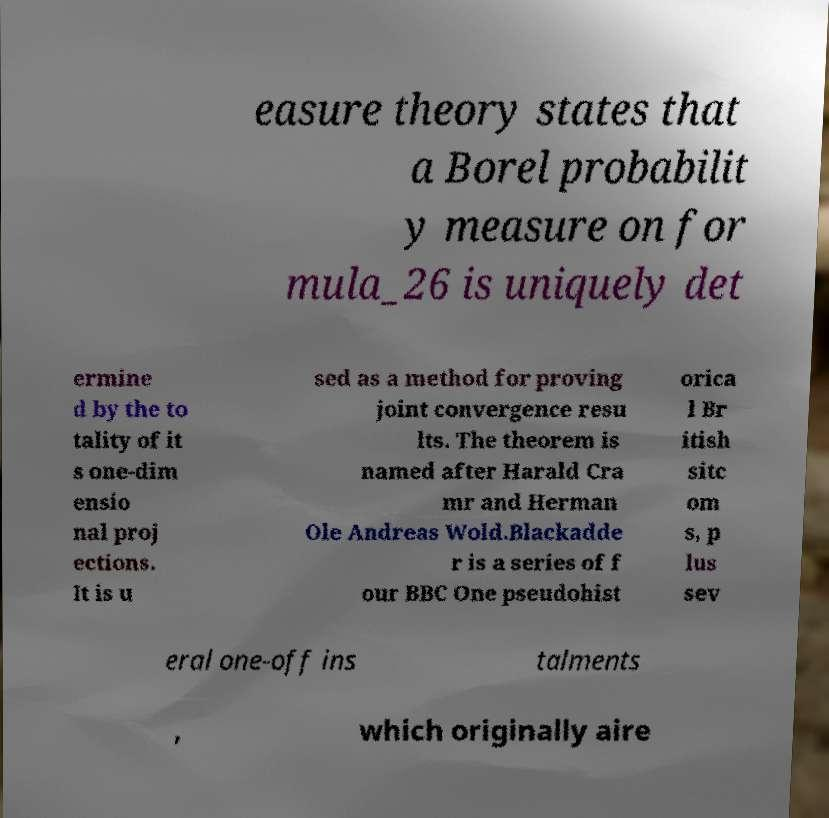Please read and relay the text visible in this image. What does it say? easure theory states that a Borel probabilit y measure on for mula_26 is uniquely det ermine d by the to tality of it s one-dim ensio nal proj ections. It is u sed as a method for proving joint convergence resu lts. The theorem is named after Harald Cra mr and Herman Ole Andreas Wold.Blackadde r is a series of f our BBC One pseudohist orica l Br itish sitc om s, p lus sev eral one-off ins talments , which originally aire 